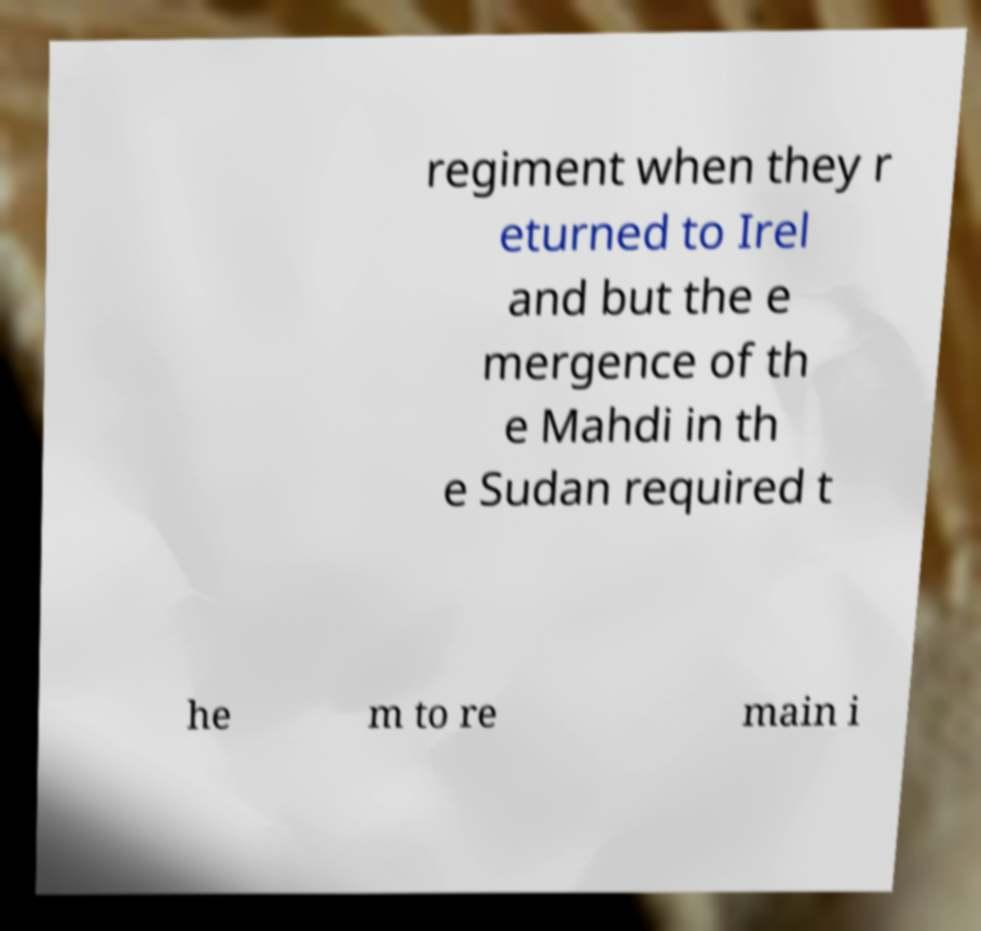Please identify and transcribe the text found in this image. regiment when they r eturned to Irel and but the e mergence of th e Mahdi in th e Sudan required t he m to re main i 